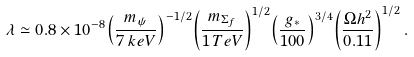<formula> <loc_0><loc_0><loc_500><loc_500>\lambda \simeq 0 . 8 \times 1 0 ^ { - 8 } { \left ( \frac { m _ { \psi } } { 7 \, k e V } \right ) } ^ { - 1 / 2 } { \left ( \frac { m _ { \Sigma _ { f } } } { 1 \, T e V } \right ) } ^ { 1 / 2 } { \left ( \frac { g _ { * } } { 1 0 0 } \right ) } ^ { 3 / 4 } { \left ( \frac { \Omega h ^ { 2 } } { 0 . 1 1 } \right ) } ^ { 1 / 2 } \, .</formula> 